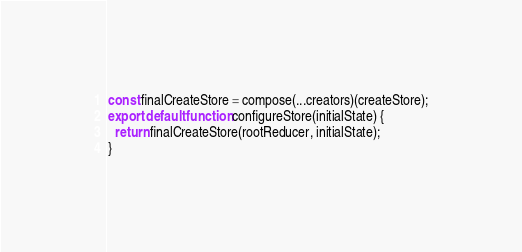Convert code to text. <code><loc_0><loc_0><loc_500><loc_500><_JavaScript_>
const finalCreateStore = compose(...creators)(createStore);
export default function configureStore(initialState) {
  return finalCreateStore(rootReducer, initialState);
}
</code> 